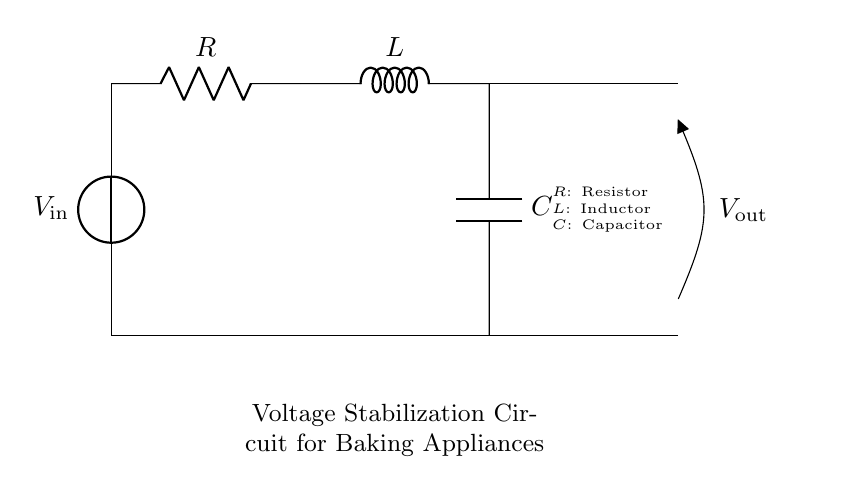What is the input voltage source in this circuit? The input voltage source is labeled as $V_\text{in}$, which indicates the voltage supplied to the circuit for operating it.
Answer: V in What is the purpose of the resistor in this circuit? The resistor is responsible for limiting the current flow through the circuit, causing a voltage drop and helping to stabilize the supply voltage for sensitive components.
Answer: Current limiting What type of components are included in this circuit? The circuit consists of a resistor, an inductor, and a capacitor, which are standard components used for voltage stabilization and filtering applications.
Answer: Resistor, inductor, capacitor How does the inductor affect voltage stabilization? The inductor opposes changes in current flow, thereby smoothing out voltage fluctuations by temporarily storing energy, which is crucial for maintaining a steady output voltage in sensitive applications.
Answer: Smooths fluctuations What happens to the output voltage when the load changes? When the load changes, the output voltage may vary unless the circuit adequately stabilizes it, by filtering and managing changes in the current that draw from the circuit.
Answer: Varies What is the function of the capacitor in this setup? The capacitor works to store energy and release it when needed, helping to maintain a stable voltage across the load by filtering out high-frequency noise and smoothing the output voltage.
Answer: Voltage smoothing 